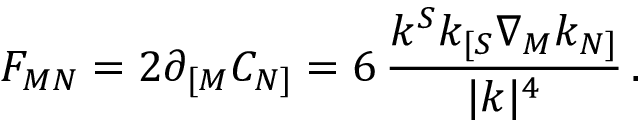Convert formula to latex. <formula><loc_0><loc_0><loc_500><loc_500>F _ { M N } = 2 \partial _ { [ M } C _ { N ] } = 6 \, { \frac { k ^ { S } k _ { [ S } \nabla _ { M } k _ { N ] } } { | k | ^ { 4 } } } \, .</formula> 